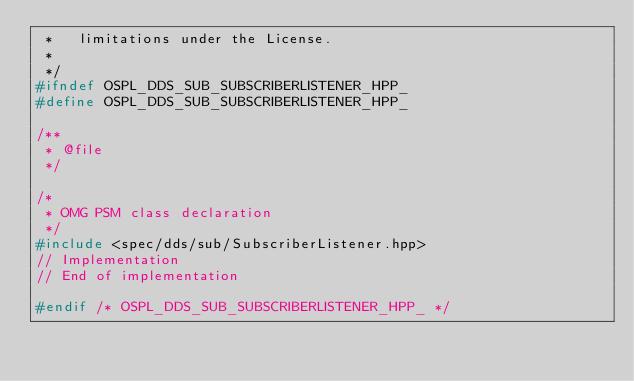Convert code to text. <code><loc_0><loc_0><loc_500><loc_500><_C++_> *   limitations under the License.
 *
 */
#ifndef OSPL_DDS_SUB_SUBSCRIBERLISTENER_HPP_
#define OSPL_DDS_SUB_SUBSCRIBERLISTENER_HPP_

/**
 * @file
 */

/*
 * OMG PSM class declaration
 */
#include <spec/dds/sub/SubscriberListener.hpp>
// Implementation
// End of implementation

#endif /* OSPL_DDS_SUB_SUBSCRIBERLISTENER_HPP_ */
</code> 